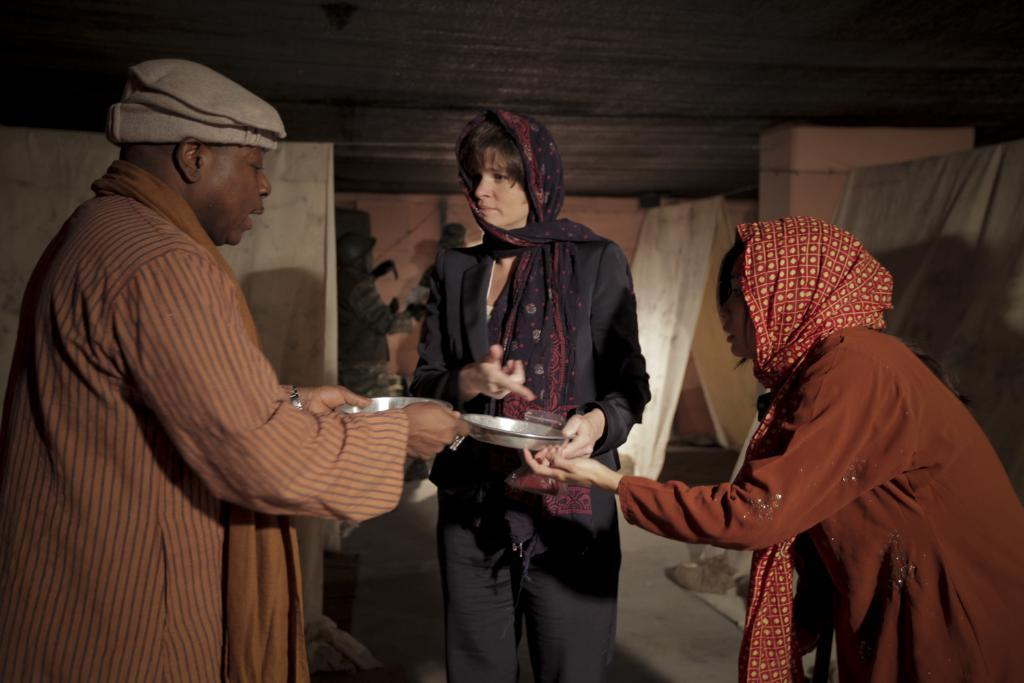How many people are present in the image? There are three people in the image: one man and two women. What are the people in the image doing? The man and women are standing on the ground. Which people are holding plates in the image? Two people, one man and one woman, are holding plates with their hands. What can be seen in the background of the image? There is a wall in the background of the image. What type of cannon is being used by the man in the image? There is no cannon present in the image; the man is simply standing on the ground. What organization do the people in the image belong to? There is no information about any organization in the image; it only shows three people standing and holding plates. 